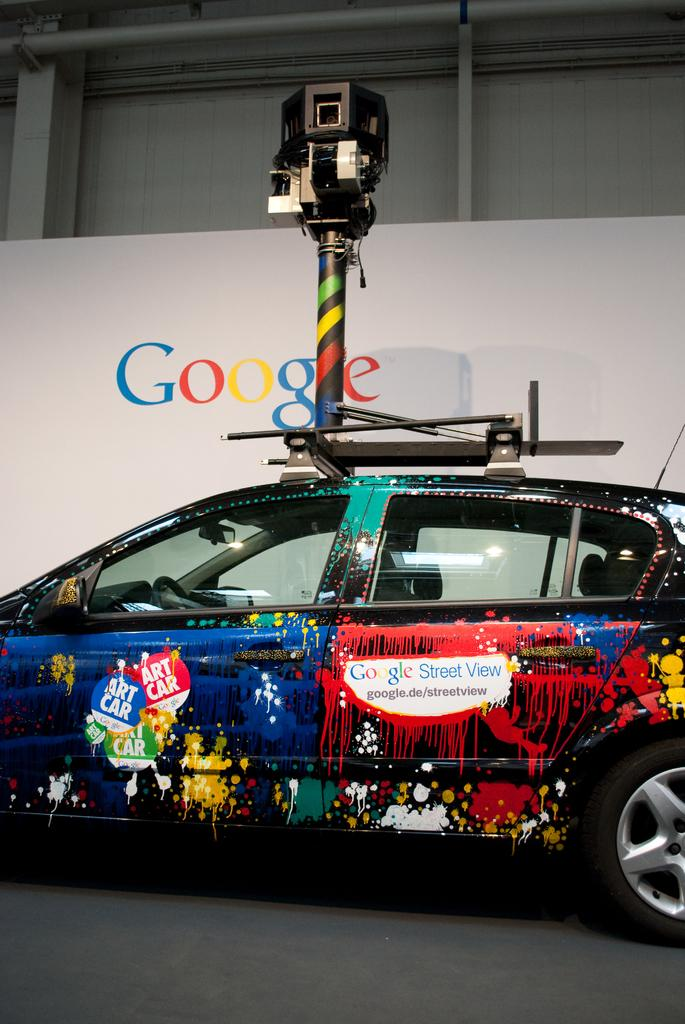What is the main subject of the image? There is a car on the road in the image. What can be seen in the background of the image? There is a pole and a wall in the background of the image. Are there any openings visible in the background? Yes, there are windows visible in the background of the image. How many birds are perched on the car in the image? There are no birds present in the image; it only features a car on the road and elements in the background. 